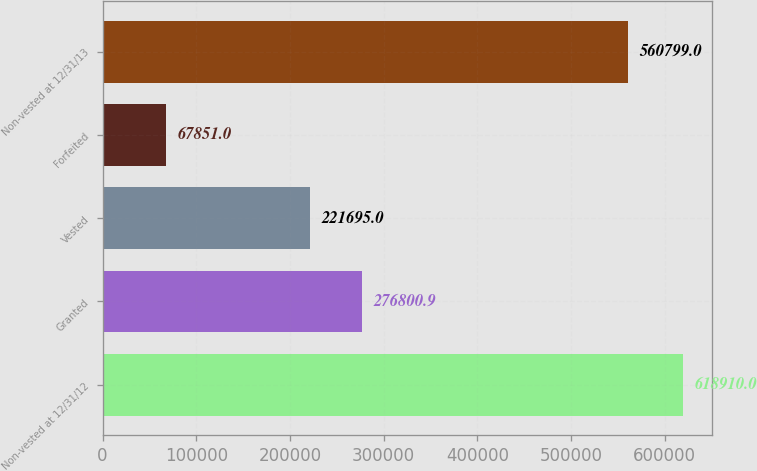Convert chart. <chart><loc_0><loc_0><loc_500><loc_500><bar_chart><fcel>Non-vested at 12/31/12<fcel>Granted<fcel>Vested<fcel>Forfeited<fcel>Non-vested at 12/31/13<nl><fcel>618910<fcel>276801<fcel>221695<fcel>67851<fcel>560799<nl></chart> 